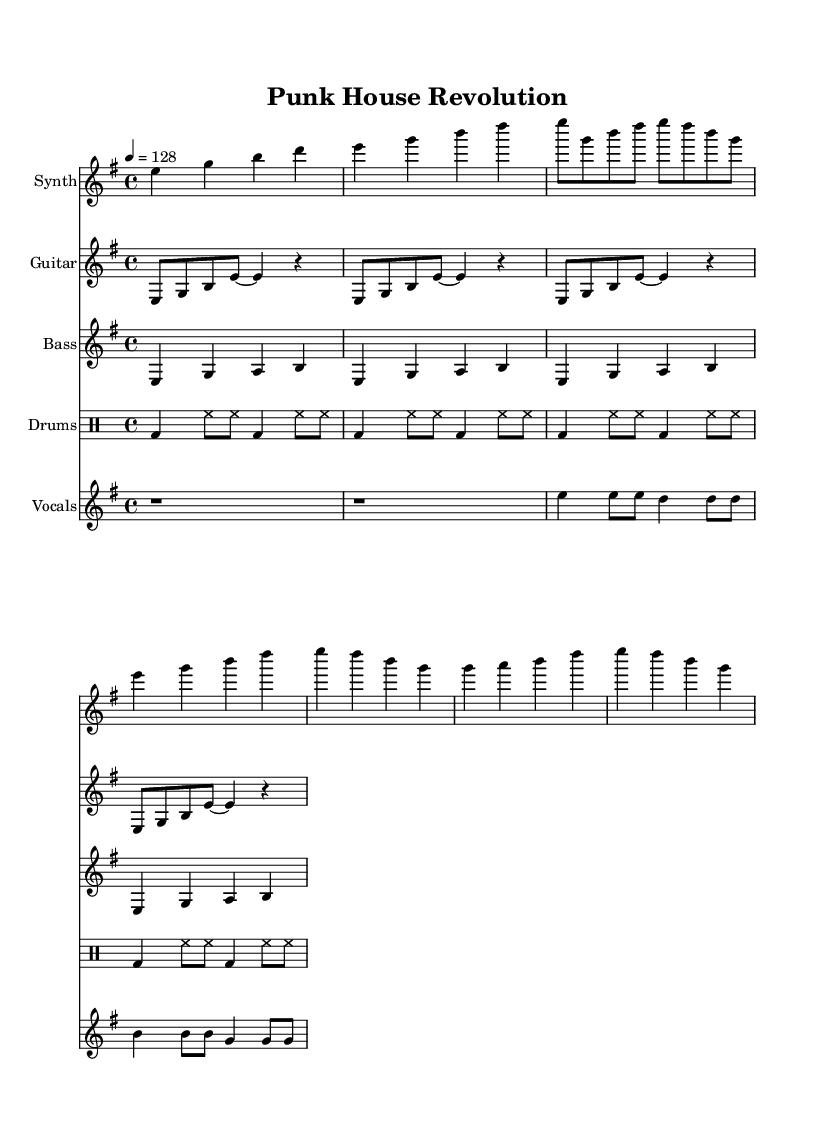What is the key signature of this music? The key signature is E minor, which contains one sharp (F#) and is indicated at the beginning of the staff in the music sheet.
Answer: E minor What is the time signature of this music? The time signature is 4/4, meaning there are four beats in each measure and the quarter note gets one beat. It is displayed at the beginning of the piece next to the key signature.
Answer: 4/4 What is the tempo marking in this music? The tempo marking is 4 equals 128, which signifies that there are 128 beats per minute using a quarter note as the beat. This information is detailed at the start of the score.
Answer: 128 How many measures are in the guitar riff? The guitar riff consists of four measures, as each line contains four musical phrases separated by bar lines.
Answer: 4 What instruments are present in this composition? The composition features a synthesizer, guitar, bass, drums, and vocals, as indicated by their respective labels in the score.
Answer: Synth, Guitar, Bass, Drums, Vocals What is the distinguishing characteristic of the vocal part in this piece? The vocal part features lyrics that emphasize themes of breaking barriers and fusing sounds, which aligns with the punk-influenced nature of the music.
Answer: Lyrics about breaking barriers 